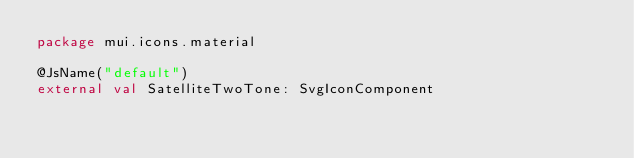Convert code to text. <code><loc_0><loc_0><loc_500><loc_500><_Kotlin_>package mui.icons.material

@JsName("default")
external val SatelliteTwoTone: SvgIconComponent
</code> 